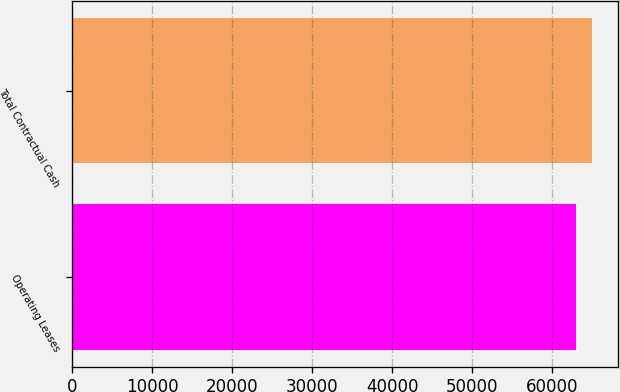Convert chart to OTSL. <chart><loc_0><loc_0><loc_500><loc_500><bar_chart><fcel>Operating Leases<fcel>Total Contractual Cash<nl><fcel>62934<fcel>64964<nl></chart> 